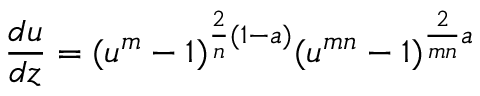<formula> <loc_0><loc_0><loc_500><loc_500>{ \frac { d u } { d z } } = ( u ^ { m } - 1 ) ^ { { \frac { 2 } { n } } ( 1 - a ) } ( u ^ { m n } - 1 ) ^ { { \frac { 2 } { m n } } a }</formula> 